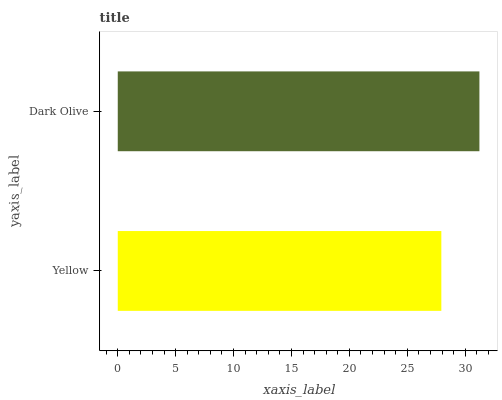Is Yellow the minimum?
Answer yes or no. Yes. Is Dark Olive the maximum?
Answer yes or no. Yes. Is Dark Olive the minimum?
Answer yes or no. No. Is Dark Olive greater than Yellow?
Answer yes or no. Yes. Is Yellow less than Dark Olive?
Answer yes or no. Yes. Is Yellow greater than Dark Olive?
Answer yes or no. No. Is Dark Olive less than Yellow?
Answer yes or no. No. Is Dark Olive the high median?
Answer yes or no. Yes. Is Yellow the low median?
Answer yes or no. Yes. Is Yellow the high median?
Answer yes or no. No. Is Dark Olive the low median?
Answer yes or no. No. 